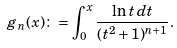<formula> <loc_0><loc_0><loc_500><loc_500>g _ { n } ( x ) \colon = \int _ { 0 } ^ { x } \frac { \ln t \, d t } { ( t ^ { 2 } + 1 ) ^ { n + 1 } } .</formula> 